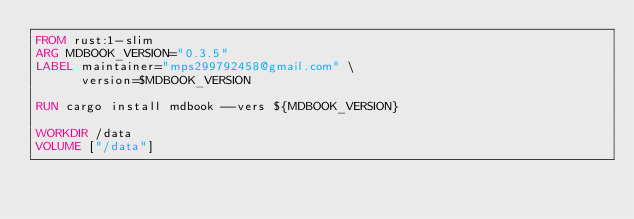Convert code to text. <code><loc_0><loc_0><loc_500><loc_500><_Dockerfile_>FROM rust:1-slim
ARG MDBOOK_VERSION="0.3.5"
LABEL maintainer="mps299792458@gmail.com" \
      version=$MDBOOK_VERSION

RUN cargo install mdbook --vers ${MDBOOK_VERSION}

WORKDIR /data
VOLUME ["/data"]
</code> 